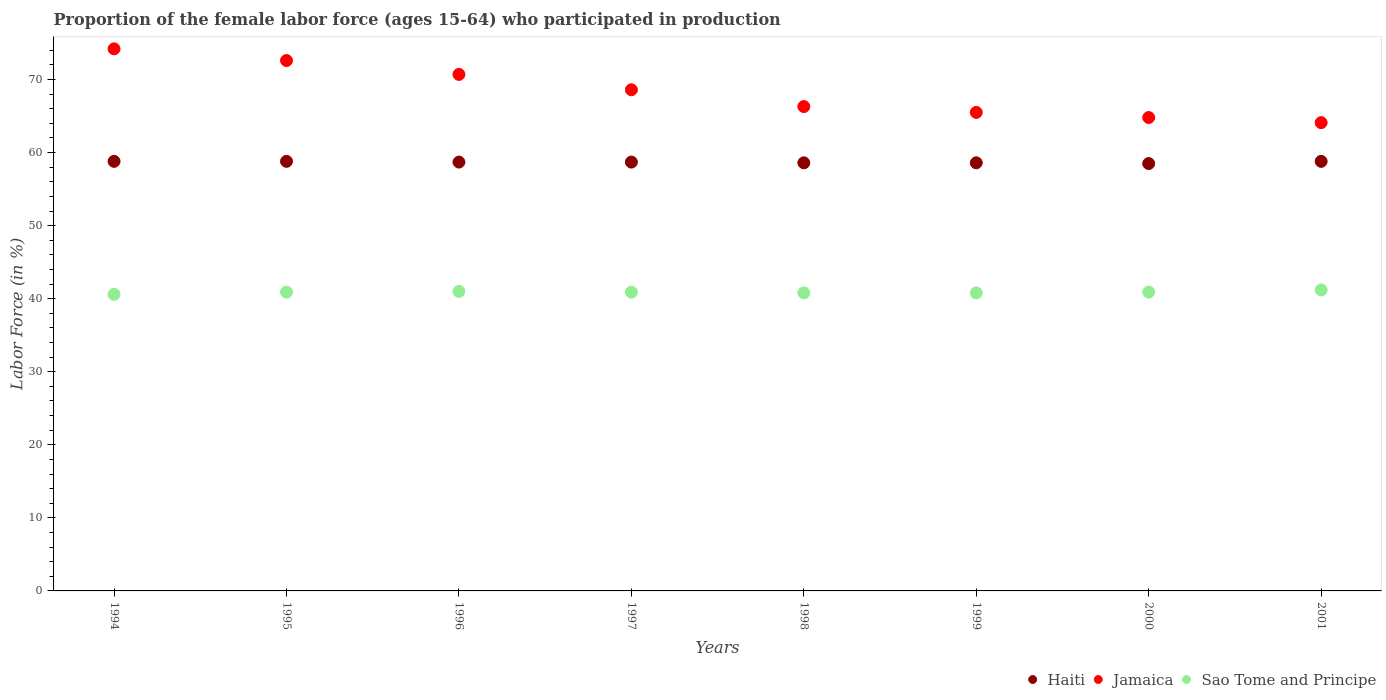How many different coloured dotlines are there?
Offer a terse response. 3. What is the proportion of the female labor force who participated in production in Sao Tome and Principe in 2001?
Ensure brevity in your answer.  41.2. Across all years, what is the maximum proportion of the female labor force who participated in production in Sao Tome and Principe?
Your answer should be compact. 41.2. Across all years, what is the minimum proportion of the female labor force who participated in production in Haiti?
Give a very brief answer. 58.5. In which year was the proportion of the female labor force who participated in production in Haiti maximum?
Offer a very short reply. 1994. In which year was the proportion of the female labor force who participated in production in Jamaica minimum?
Your response must be concise. 2001. What is the total proportion of the female labor force who participated in production in Haiti in the graph?
Offer a terse response. 469.5. What is the difference between the proportion of the female labor force who participated in production in Jamaica in 1995 and that in 1999?
Keep it short and to the point. 7.1. What is the difference between the proportion of the female labor force who participated in production in Sao Tome and Principe in 1994 and the proportion of the female labor force who participated in production in Haiti in 1997?
Your answer should be very brief. -18.1. What is the average proportion of the female labor force who participated in production in Jamaica per year?
Provide a short and direct response. 68.35. In the year 1997, what is the difference between the proportion of the female labor force who participated in production in Haiti and proportion of the female labor force who participated in production in Sao Tome and Principe?
Offer a terse response. 17.8. What is the ratio of the proportion of the female labor force who participated in production in Sao Tome and Principe in 1996 to that in 1998?
Offer a terse response. 1. Is the proportion of the female labor force who participated in production in Sao Tome and Principe in 1998 less than that in 1999?
Your response must be concise. No. What is the difference between the highest and the lowest proportion of the female labor force who participated in production in Jamaica?
Keep it short and to the point. 10.1. In how many years, is the proportion of the female labor force who participated in production in Sao Tome and Principe greater than the average proportion of the female labor force who participated in production in Sao Tome and Principe taken over all years?
Ensure brevity in your answer.  5. Is the sum of the proportion of the female labor force who participated in production in Sao Tome and Principe in 1994 and 1995 greater than the maximum proportion of the female labor force who participated in production in Haiti across all years?
Your response must be concise. Yes. Is it the case that in every year, the sum of the proportion of the female labor force who participated in production in Sao Tome and Principe and proportion of the female labor force who participated in production in Jamaica  is greater than the proportion of the female labor force who participated in production in Haiti?
Make the answer very short. Yes. Is the proportion of the female labor force who participated in production in Sao Tome and Principe strictly less than the proportion of the female labor force who participated in production in Jamaica over the years?
Provide a short and direct response. Yes. How many years are there in the graph?
Your answer should be very brief. 8. What is the difference between two consecutive major ticks on the Y-axis?
Your answer should be compact. 10. Are the values on the major ticks of Y-axis written in scientific E-notation?
Your answer should be compact. No. What is the title of the graph?
Offer a very short reply. Proportion of the female labor force (ages 15-64) who participated in production. Does "Curacao" appear as one of the legend labels in the graph?
Ensure brevity in your answer.  No. What is the label or title of the X-axis?
Provide a short and direct response. Years. What is the Labor Force (in %) in Haiti in 1994?
Offer a terse response. 58.8. What is the Labor Force (in %) in Jamaica in 1994?
Ensure brevity in your answer.  74.2. What is the Labor Force (in %) in Sao Tome and Principe in 1994?
Your response must be concise. 40.6. What is the Labor Force (in %) of Haiti in 1995?
Give a very brief answer. 58.8. What is the Labor Force (in %) of Jamaica in 1995?
Make the answer very short. 72.6. What is the Labor Force (in %) in Sao Tome and Principe in 1995?
Make the answer very short. 40.9. What is the Labor Force (in %) of Haiti in 1996?
Offer a terse response. 58.7. What is the Labor Force (in %) of Jamaica in 1996?
Your response must be concise. 70.7. What is the Labor Force (in %) in Haiti in 1997?
Make the answer very short. 58.7. What is the Labor Force (in %) of Jamaica in 1997?
Provide a short and direct response. 68.6. What is the Labor Force (in %) in Sao Tome and Principe in 1997?
Your answer should be very brief. 40.9. What is the Labor Force (in %) in Haiti in 1998?
Your response must be concise. 58.6. What is the Labor Force (in %) of Jamaica in 1998?
Your response must be concise. 66.3. What is the Labor Force (in %) of Sao Tome and Principe in 1998?
Offer a terse response. 40.8. What is the Labor Force (in %) of Haiti in 1999?
Your answer should be very brief. 58.6. What is the Labor Force (in %) of Jamaica in 1999?
Your answer should be compact. 65.5. What is the Labor Force (in %) in Sao Tome and Principe in 1999?
Provide a succinct answer. 40.8. What is the Labor Force (in %) in Haiti in 2000?
Give a very brief answer. 58.5. What is the Labor Force (in %) of Jamaica in 2000?
Give a very brief answer. 64.8. What is the Labor Force (in %) of Sao Tome and Principe in 2000?
Ensure brevity in your answer.  40.9. What is the Labor Force (in %) of Haiti in 2001?
Your answer should be compact. 58.8. What is the Labor Force (in %) in Jamaica in 2001?
Offer a very short reply. 64.1. What is the Labor Force (in %) of Sao Tome and Principe in 2001?
Your response must be concise. 41.2. Across all years, what is the maximum Labor Force (in %) in Haiti?
Ensure brevity in your answer.  58.8. Across all years, what is the maximum Labor Force (in %) in Jamaica?
Ensure brevity in your answer.  74.2. Across all years, what is the maximum Labor Force (in %) in Sao Tome and Principe?
Offer a very short reply. 41.2. Across all years, what is the minimum Labor Force (in %) of Haiti?
Ensure brevity in your answer.  58.5. Across all years, what is the minimum Labor Force (in %) of Jamaica?
Provide a succinct answer. 64.1. Across all years, what is the minimum Labor Force (in %) of Sao Tome and Principe?
Offer a terse response. 40.6. What is the total Labor Force (in %) in Haiti in the graph?
Provide a short and direct response. 469.5. What is the total Labor Force (in %) in Jamaica in the graph?
Make the answer very short. 546.8. What is the total Labor Force (in %) in Sao Tome and Principe in the graph?
Your response must be concise. 327.1. What is the difference between the Labor Force (in %) of Haiti in 1994 and that in 1995?
Offer a terse response. 0. What is the difference between the Labor Force (in %) of Jamaica in 1994 and that in 1996?
Make the answer very short. 3.5. What is the difference between the Labor Force (in %) of Sao Tome and Principe in 1994 and that in 1997?
Your answer should be very brief. -0.3. What is the difference between the Labor Force (in %) in Sao Tome and Principe in 1994 and that in 1998?
Offer a terse response. -0.2. What is the difference between the Labor Force (in %) of Jamaica in 1994 and that in 1999?
Give a very brief answer. 8.7. What is the difference between the Labor Force (in %) of Jamaica in 1994 and that in 2000?
Offer a terse response. 9.4. What is the difference between the Labor Force (in %) in Sao Tome and Principe in 1994 and that in 2000?
Your answer should be very brief. -0.3. What is the difference between the Labor Force (in %) of Haiti in 1994 and that in 2001?
Your response must be concise. 0. What is the difference between the Labor Force (in %) in Haiti in 1995 and that in 1998?
Your answer should be compact. 0.2. What is the difference between the Labor Force (in %) of Jamaica in 1995 and that in 1998?
Your answer should be very brief. 6.3. What is the difference between the Labor Force (in %) of Sao Tome and Principe in 1995 and that in 1998?
Offer a very short reply. 0.1. What is the difference between the Labor Force (in %) of Jamaica in 1995 and that in 1999?
Ensure brevity in your answer.  7.1. What is the difference between the Labor Force (in %) of Haiti in 1995 and that in 2000?
Make the answer very short. 0.3. What is the difference between the Labor Force (in %) in Jamaica in 1995 and that in 2000?
Offer a very short reply. 7.8. What is the difference between the Labor Force (in %) in Sao Tome and Principe in 1995 and that in 2000?
Provide a succinct answer. 0. What is the difference between the Labor Force (in %) in Jamaica in 1995 and that in 2001?
Make the answer very short. 8.5. What is the difference between the Labor Force (in %) of Sao Tome and Principe in 1995 and that in 2001?
Offer a terse response. -0.3. What is the difference between the Labor Force (in %) in Haiti in 1996 and that in 1997?
Give a very brief answer. 0. What is the difference between the Labor Force (in %) in Sao Tome and Principe in 1996 and that in 1997?
Give a very brief answer. 0.1. What is the difference between the Labor Force (in %) in Haiti in 1996 and that in 1998?
Provide a short and direct response. 0.1. What is the difference between the Labor Force (in %) in Sao Tome and Principe in 1996 and that in 1999?
Your response must be concise. 0.2. What is the difference between the Labor Force (in %) in Jamaica in 1996 and that in 2001?
Keep it short and to the point. 6.6. What is the difference between the Labor Force (in %) in Haiti in 1997 and that in 1999?
Offer a terse response. 0.1. What is the difference between the Labor Force (in %) of Jamaica in 1997 and that in 2000?
Give a very brief answer. 3.8. What is the difference between the Labor Force (in %) in Haiti in 1997 and that in 2001?
Keep it short and to the point. -0.1. What is the difference between the Labor Force (in %) in Haiti in 1998 and that in 1999?
Ensure brevity in your answer.  0. What is the difference between the Labor Force (in %) of Jamaica in 1998 and that in 1999?
Your response must be concise. 0.8. What is the difference between the Labor Force (in %) in Sao Tome and Principe in 1998 and that in 1999?
Offer a terse response. 0. What is the difference between the Labor Force (in %) in Haiti in 1998 and that in 2000?
Provide a succinct answer. 0.1. What is the difference between the Labor Force (in %) of Jamaica in 1998 and that in 2000?
Offer a terse response. 1.5. What is the difference between the Labor Force (in %) of Sao Tome and Principe in 1998 and that in 2000?
Keep it short and to the point. -0.1. What is the difference between the Labor Force (in %) of Haiti in 1998 and that in 2001?
Give a very brief answer. -0.2. What is the difference between the Labor Force (in %) in Haiti in 1999 and that in 2000?
Provide a succinct answer. 0.1. What is the difference between the Labor Force (in %) in Jamaica in 1999 and that in 2000?
Your answer should be compact. 0.7. What is the difference between the Labor Force (in %) in Sao Tome and Principe in 1999 and that in 2000?
Your answer should be very brief. -0.1. What is the difference between the Labor Force (in %) of Jamaica in 1999 and that in 2001?
Ensure brevity in your answer.  1.4. What is the difference between the Labor Force (in %) in Jamaica in 2000 and that in 2001?
Keep it short and to the point. 0.7. What is the difference between the Labor Force (in %) in Haiti in 1994 and the Labor Force (in %) in Jamaica in 1995?
Your answer should be very brief. -13.8. What is the difference between the Labor Force (in %) of Jamaica in 1994 and the Labor Force (in %) of Sao Tome and Principe in 1995?
Provide a succinct answer. 33.3. What is the difference between the Labor Force (in %) in Haiti in 1994 and the Labor Force (in %) in Jamaica in 1996?
Offer a terse response. -11.9. What is the difference between the Labor Force (in %) of Haiti in 1994 and the Labor Force (in %) of Sao Tome and Principe in 1996?
Your answer should be compact. 17.8. What is the difference between the Labor Force (in %) of Jamaica in 1994 and the Labor Force (in %) of Sao Tome and Principe in 1996?
Keep it short and to the point. 33.2. What is the difference between the Labor Force (in %) in Haiti in 1994 and the Labor Force (in %) in Jamaica in 1997?
Give a very brief answer. -9.8. What is the difference between the Labor Force (in %) in Jamaica in 1994 and the Labor Force (in %) in Sao Tome and Principe in 1997?
Offer a terse response. 33.3. What is the difference between the Labor Force (in %) of Haiti in 1994 and the Labor Force (in %) of Sao Tome and Principe in 1998?
Offer a very short reply. 18. What is the difference between the Labor Force (in %) in Jamaica in 1994 and the Labor Force (in %) in Sao Tome and Principe in 1998?
Provide a succinct answer. 33.4. What is the difference between the Labor Force (in %) of Haiti in 1994 and the Labor Force (in %) of Jamaica in 1999?
Your answer should be very brief. -6.7. What is the difference between the Labor Force (in %) in Jamaica in 1994 and the Labor Force (in %) in Sao Tome and Principe in 1999?
Offer a terse response. 33.4. What is the difference between the Labor Force (in %) in Haiti in 1994 and the Labor Force (in %) in Sao Tome and Principe in 2000?
Your answer should be very brief. 17.9. What is the difference between the Labor Force (in %) in Jamaica in 1994 and the Labor Force (in %) in Sao Tome and Principe in 2000?
Provide a succinct answer. 33.3. What is the difference between the Labor Force (in %) in Haiti in 1994 and the Labor Force (in %) in Jamaica in 2001?
Provide a short and direct response. -5.3. What is the difference between the Labor Force (in %) of Haiti in 1995 and the Labor Force (in %) of Jamaica in 1996?
Offer a very short reply. -11.9. What is the difference between the Labor Force (in %) of Haiti in 1995 and the Labor Force (in %) of Sao Tome and Principe in 1996?
Your answer should be very brief. 17.8. What is the difference between the Labor Force (in %) in Jamaica in 1995 and the Labor Force (in %) in Sao Tome and Principe in 1996?
Offer a terse response. 31.6. What is the difference between the Labor Force (in %) of Haiti in 1995 and the Labor Force (in %) of Sao Tome and Principe in 1997?
Offer a terse response. 17.9. What is the difference between the Labor Force (in %) in Jamaica in 1995 and the Labor Force (in %) in Sao Tome and Principe in 1997?
Your answer should be very brief. 31.7. What is the difference between the Labor Force (in %) of Haiti in 1995 and the Labor Force (in %) of Sao Tome and Principe in 1998?
Make the answer very short. 18. What is the difference between the Labor Force (in %) in Jamaica in 1995 and the Labor Force (in %) in Sao Tome and Principe in 1998?
Ensure brevity in your answer.  31.8. What is the difference between the Labor Force (in %) of Haiti in 1995 and the Labor Force (in %) of Jamaica in 1999?
Ensure brevity in your answer.  -6.7. What is the difference between the Labor Force (in %) in Jamaica in 1995 and the Labor Force (in %) in Sao Tome and Principe in 1999?
Keep it short and to the point. 31.8. What is the difference between the Labor Force (in %) in Haiti in 1995 and the Labor Force (in %) in Jamaica in 2000?
Make the answer very short. -6. What is the difference between the Labor Force (in %) of Jamaica in 1995 and the Labor Force (in %) of Sao Tome and Principe in 2000?
Offer a very short reply. 31.7. What is the difference between the Labor Force (in %) of Haiti in 1995 and the Labor Force (in %) of Jamaica in 2001?
Give a very brief answer. -5.3. What is the difference between the Labor Force (in %) in Haiti in 1995 and the Labor Force (in %) in Sao Tome and Principe in 2001?
Provide a short and direct response. 17.6. What is the difference between the Labor Force (in %) in Jamaica in 1995 and the Labor Force (in %) in Sao Tome and Principe in 2001?
Provide a succinct answer. 31.4. What is the difference between the Labor Force (in %) of Jamaica in 1996 and the Labor Force (in %) of Sao Tome and Principe in 1997?
Ensure brevity in your answer.  29.8. What is the difference between the Labor Force (in %) in Haiti in 1996 and the Labor Force (in %) in Jamaica in 1998?
Your answer should be compact. -7.6. What is the difference between the Labor Force (in %) in Jamaica in 1996 and the Labor Force (in %) in Sao Tome and Principe in 1998?
Your response must be concise. 29.9. What is the difference between the Labor Force (in %) of Jamaica in 1996 and the Labor Force (in %) of Sao Tome and Principe in 1999?
Give a very brief answer. 29.9. What is the difference between the Labor Force (in %) of Haiti in 1996 and the Labor Force (in %) of Jamaica in 2000?
Offer a very short reply. -6.1. What is the difference between the Labor Force (in %) of Jamaica in 1996 and the Labor Force (in %) of Sao Tome and Principe in 2000?
Your answer should be very brief. 29.8. What is the difference between the Labor Force (in %) of Haiti in 1996 and the Labor Force (in %) of Sao Tome and Principe in 2001?
Your response must be concise. 17.5. What is the difference between the Labor Force (in %) of Jamaica in 1996 and the Labor Force (in %) of Sao Tome and Principe in 2001?
Your answer should be very brief. 29.5. What is the difference between the Labor Force (in %) of Haiti in 1997 and the Labor Force (in %) of Sao Tome and Principe in 1998?
Provide a succinct answer. 17.9. What is the difference between the Labor Force (in %) of Jamaica in 1997 and the Labor Force (in %) of Sao Tome and Principe in 1998?
Your answer should be very brief. 27.8. What is the difference between the Labor Force (in %) in Jamaica in 1997 and the Labor Force (in %) in Sao Tome and Principe in 1999?
Ensure brevity in your answer.  27.8. What is the difference between the Labor Force (in %) in Haiti in 1997 and the Labor Force (in %) in Jamaica in 2000?
Offer a terse response. -6.1. What is the difference between the Labor Force (in %) in Haiti in 1997 and the Labor Force (in %) in Sao Tome and Principe in 2000?
Offer a very short reply. 17.8. What is the difference between the Labor Force (in %) in Jamaica in 1997 and the Labor Force (in %) in Sao Tome and Principe in 2000?
Your response must be concise. 27.7. What is the difference between the Labor Force (in %) of Haiti in 1997 and the Labor Force (in %) of Jamaica in 2001?
Offer a very short reply. -5.4. What is the difference between the Labor Force (in %) of Haiti in 1997 and the Labor Force (in %) of Sao Tome and Principe in 2001?
Offer a terse response. 17.5. What is the difference between the Labor Force (in %) in Jamaica in 1997 and the Labor Force (in %) in Sao Tome and Principe in 2001?
Provide a succinct answer. 27.4. What is the difference between the Labor Force (in %) in Haiti in 1998 and the Labor Force (in %) in Jamaica in 1999?
Keep it short and to the point. -6.9. What is the difference between the Labor Force (in %) of Haiti in 1998 and the Labor Force (in %) of Sao Tome and Principe in 1999?
Give a very brief answer. 17.8. What is the difference between the Labor Force (in %) in Jamaica in 1998 and the Labor Force (in %) in Sao Tome and Principe in 1999?
Provide a succinct answer. 25.5. What is the difference between the Labor Force (in %) of Haiti in 1998 and the Labor Force (in %) of Jamaica in 2000?
Make the answer very short. -6.2. What is the difference between the Labor Force (in %) in Jamaica in 1998 and the Labor Force (in %) in Sao Tome and Principe in 2000?
Your answer should be very brief. 25.4. What is the difference between the Labor Force (in %) of Haiti in 1998 and the Labor Force (in %) of Jamaica in 2001?
Make the answer very short. -5.5. What is the difference between the Labor Force (in %) of Haiti in 1998 and the Labor Force (in %) of Sao Tome and Principe in 2001?
Your answer should be very brief. 17.4. What is the difference between the Labor Force (in %) in Jamaica in 1998 and the Labor Force (in %) in Sao Tome and Principe in 2001?
Provide a short and direct response. 25.1. What is the difference between the Labor Force (in %) of Haiti in 1999 and the Labor Force (in %) of Jamaica in 2000?
Ensure brevity in your answer.  -6.2. What is the difference between the Labor Force (in %) of Haiti in 1999 and the Labor Force (in %) of Sao Tome and Principe in 2000?
Your response must be concise. 17.7. What is the difference between the Labor Force (in %) in Jamaica in 1999 and the Labor Force (in %) in Sao Tome and Principe in 2000?
Offer a terse response. 24.6. What is the difference between the Labor Force (in %) of Haiti in 1999 and the Labor Force (in %) of Sao Tome and Principe in 2001?
Ensure brevity in your answer.  17.4. What is the difference between the Labor Force (in %) in Jamaica in 1999 and the Labor Force (in %) in Sao Tome and Principe in 2001?
Make the answer very short. 24.3. What is the difference between the Labor Force (in %) of Haiti in 2000 and the Labor Force (in %) of Jamaica in 2001?
Your response must be concise. -5.6. What is the difference between the Labor Force (in %) of Jamaica in 2000 and the Labor Force (in %) of Sao Tome and Principe in 2001?
Ensure brevity in your answer.  23.6. What is the average Labor Force (in %) in Haiti per year?
Offer a terse response. 58.69. What is the average Labor Force (in %) of Jamaica per year?
Make the answer very short. 68.35. What is the average Labor Force (in %) of Sao Tome and Principe per year?
Make the answer very short. 40.89. In the year 1994, what is the difference between the Labor Force (in %) of Haiti and Labor Force (in %) of Jamaica?
Ensure brevity in your answer.  -15.4. In the year 1994, what is the difference between the Labor Force (in %) in Jamaica and Labor Force (in %) in Sao Tome and Principe?
Make the answer very short. 33.6. In the year 1995, what is the difference between the Labor Force (in %) in Haiti and Labor Force (in %) in Jamaica?
Your response must be concise. -13.8. In the year 1995, what is the difference between the Labor Force (in %) of Haiti and Labor Force (in %) of Sao Tome and Principe?
Keep it short and to the point. 17.9. In the year 1995, what is the difference between the Labor Force (in %) in Jamaica and Labor Force (in %) in Sao Tome and Principe?
Make the answer very short. 31.7. In the year 1996, what is the difference between the Labor Force (in %) in Haiti and Labor Force (in %) in Jamaica?
Keep it short and to the point. -12. In the year 1996, what is the difference between the Labor Force (in %) in Haiti and Labor Force (in %) in Sao Tome and Principe?
Your response must be concise. 17.7. In the year 1996, what is the difference between the Labor Force (in %) of Jamaica and Labor Force (in %) of Sao Tome and Principe?
Give a very brief answer. 29.7. In the year 1997, what is the difference between the Labor Force (in %) of Haiti and Labor Force (in %) of Sao Tome and Principe?
Your answer should be very brief. 17.8. In the year 1997, what is the difference between the Labor Force (in %) of Jamaica and Labor Force (in %) of Sao Tome and Principe?
Offer a very short reply. 27.7. In the year 1998, what is the difference between the Labor Force (in %) of Haiti and Labor Force (in %) of Jamaica?
Your answer should be very brief. -7.7. In the year 1998, what is the difference between the Labor Force (in %) of Haiti and Labor Force (in %) of Sao Tome and Principe?
Make the answer very short. 17.8. In the year 1998, what is the difference between the Labor Force (in %) in Jamaica and Labor Force (in %) in Sao Tome and Principe?
Your response must be concise. 25.5. In the year 1999, what is the difference between the Labor Force (in %) of Haiti and Labor Force (in %) of Sao Tome and Principe?
Offer a very short reply. 17.8. In the year 1999, what is the difference between the Labor Force (in %) of Jamaica and Labor Force (in %) of Sao Tome and Principe?
Make the answer very short. 24.7. In the year 2000, what is the difference between the Labor Force (in %) in Haiti and Labor Force (in %) in Sao Tome and Principe?
Provide a short and direct response. 17.6. In the year 2000, what is the difference between the Labor Force (in %) of Jamaica and Labor Force (in %) of Sao Tome and Principe?
Keep it short and to the point. 23.9. In the year 2001, what is the difference between the Labor Force (in %) of Haiti and Labor Force (in %) of Jamaica?
Ensure brevity in your answer.  -5.3. In the year 2001, what is the difference between the Labor Force (in %) in Jamaica and Labor Force (in %) in Sao Tome and Principe?
Offer a terse response. 22.9. What is the ratio of the Labor Force (in %) in Haiti in 1994 to that in 1995?
Your response must be concise. 1. What is the ratio of the Labor Force (in %) of Haiti in 1994 to that in 1996?
Your answer should be very brief. 1. What is the ratio of the Labor Force (in %) in Jamaica in 1994 to that in 1996?
Offer a very short reply. 1.05. What is the ratio of the Labor Force (in %) in Sao Tome and Principe in 1994 to that in 1996?
Provide a succinct answer. 0.99. What is the ratio of the Labor Force (in %) of Haiti in 1994 to that in 1997?
Your answer should be compact. 1. What is the ratio of the Labor Force (in %) in Jamaica in 1994 to that in 1997?
Your answer should be very brief. 1.08. What is the ratio of the Labor Force (in %) of Jamaica in 1994 to that in 1998?
Ensure brevity in your answer.  1.12. What is the ratio of the Labor Force (in %) in Sao Tome and Principe in 1994 to that in 1998?
Provide a succinct answer. 1. What is the ratio of the Labor Force (in %) of Jamaica in 1994 to that in 1999?
Offer a terse response. 1.13. What is the ratio of the Labor Force (in %) in Sao Tome and Principe in 1994 to that in 1999?
Your answer should be very brief. 1. What is the ratio of the Labor Force (in %) of Haiti in 1994 to that in 2000?
Ensure brevity in your answer.  1.01. What is the ratio of the Labor Force (in %) of Jamaica in 1994 to that in 2000?
Your response must be concise. 1.15. What is the ratio of the Labor Force (in %) of Sao Tome and Principe in 1994 to that in 2000?
Offer a very short reply. 0.99. What is the ratio of the Labor Force (in %) in Jamaica in 1994 to that in 2001?
Provide a short and direct response. 1.16. What is the ratio of the Labor Force (in %) in Sao Tome and Principe in 1994 to that in 2001?
Make the answer very short. 0.99. What is the ratio of the Labor Force (in %) in Haiti in 1995 to that in 1996?
Ensure brevity in your answer.  1. What is the ratio of the Labor Force (in %) in Jamaica in 1995 to that in 1996?
Offer a terse response. 1.03. What is the ratio of the Labor Force (in %) of Jamaica in 1995 to that in 1997?
Your answer should be very brief. 1.06. What is the ratio of the Labor Force (in %) in Haiti in 1995 to that in 1998?
Offer a very short reply. 1. What is the ratio of the Labor Force (in %) of Jamaica in 1995 to that in 1998?
Provide a short and direct response. 1.09. What is the ratio of the Labor Force (in %) of Sao Tome and Principe in 1995 to that in 1998?
Make the answer very short. 1. What is the ratio of the Labor Force (in %) of Jamaica in 1995 to that in 1999?
Provide a succinct answer. 1.11. What is the ratio of the Labor Force (in %) in Haiti in 1995 to that in 2000?
Your answer should be compact. 1.01. What is the ratio of the Labor Force (in %) in Jamaica in 1995 to that in 2000?
Your response must be concise. 1.12. What is the ratio of the Labor Force (in %) in Sao Tome and Principe in 1995 to that in 2000?
Give a very brief answer. 1. What is the ratio of the Labor Force (in %) of Haiti in 1995 to that in 2001?
Offer a very short reply. 1. What is the ratio of the Labor Force (in %) of Jamaica in 1995 to that in 2001?
Your response must be concise. 1.13. What is the ratio of the Labor Force (in %) of Jamaica in 1996 to that in 1997?
Offer a terse response. 1.03. What is the ratio of the Labor Force (in %) of Sao Tome and Principe in 1996 to that in 1997?
Make the answer very short. 1. What is the ratio of the Labor Force (in %) of Haiti in 1996 to that in 1998?
Your answer should be compact. 1. What is the ratio of the Labor Force (in %) in Jamaica in 1996 to that in 1998?
Your answer should be very brief. 1.07. What is the ratio of the Labor Force (in %) of Sao Tome and Principe in 1996 to that in 1998?
Your answer should be very brief. 1. What is the ratio of the Labor Force (in %) in Haiti in 1996 to that in 1999?
Provide a short and direct response. 1. What is the ratio of the Labor Force (in %) in Jamaica in 1996 to that in 1999?
Offer a very short reply. 1.08. What is the ratio of the Labor Force (in %) in Haiti in 1996 to that in 2000?
Ensure brevity in your answer.  1. What is the ratio of the Labor Force (in %) of Jamaica in 1996 to that in 2000?
Provide a short and direct response. 1.09. What is the ratio of the Labor Force (in %) of Jamaica in 1996 to that in 2001?
Keep it short and to the point. 1.1. What is the ratio of the Labor Force (in %) of Haiti in 1997 to that in 1998?
Your answer should be very brief. 1. What is the ratio of the Labor Force (in %) in Jamaica in 1997 to that in 1998?
Keep it short and to the point. 1.03. What is the ratio of the Labor Force (in %) in Haiti in 1997 to that in 1999?
Make the answer very short. 1. What is the ratio of the Labor Force (in %) in Jamaica in 1997 to that in 1999?
Your answer should be very brief. 1.05. What is the ratio of the Labor Force (in %) of Jamaica in 1997 to that in 2000?
Provide a short and direct response. 1.06. What is the ratio of the Labor Force (in %) in Jamaica in 1997 to that in 2001?
Offer a terse response. 1.07. What is the ratio of the Labor Force (in %) in Sao Tome and Principe in 1997 to that in 2001?
Provide a succinct answer. 0.99. What is the ratio of the Labor Force (in %) of Jamaica in 1998 to that in 1999?
Keep it short and to the point. 1.01. What is the ratio of the Labor Force (in %) in Jamaica in 1998 to that in 2000?
Keep it short and to the point. 1.02. What is the ratio of the Labor Force (in %) in Jamaica in 1998 to that in 2001?
Offer a very short reply. 1.03. What is the ratio of the Labor Force (in %) of Sao Tome and Principe in 1998 to that in 2001?
Your answer should be very brief. 0.99. What is the ratio of the Labor Force (in %) of Haiti in 1999 to that in 2000?
Ensure brevity in your answer.  1. What is the ratio of the Labor Force (in %) of Jamaica in 1999 to that in 2000?
Your answer should be very brief. 1.01. What is the ratio of the Labor Force (in %) in Sao Tome and Principe in 1999 to that in 2000?
Your response must be concise. 1. What is the ratio of the Labor Force (in %) in Jamaica in 1999 to that in 2001?
Your response must be concise. 1.02. What is the ratio of the Labor Force (in %) in Sao Tome and Principe in 1999 to that in 2001?
Your response must be concise. 0.99. What is the ratio of the Labor Force (in %) of Haiti in 2000 to that in 2001?
Provide a succinct answer. 0.99. What is the ratio of the Labor Force (in %) of Jamaica in 2000 to that in 2001?
Make the answer very short. 1.01. What is the difference between the highest and the second highest Labor Force (in %) of Haiti?
Your answer should be very brief. 0. 